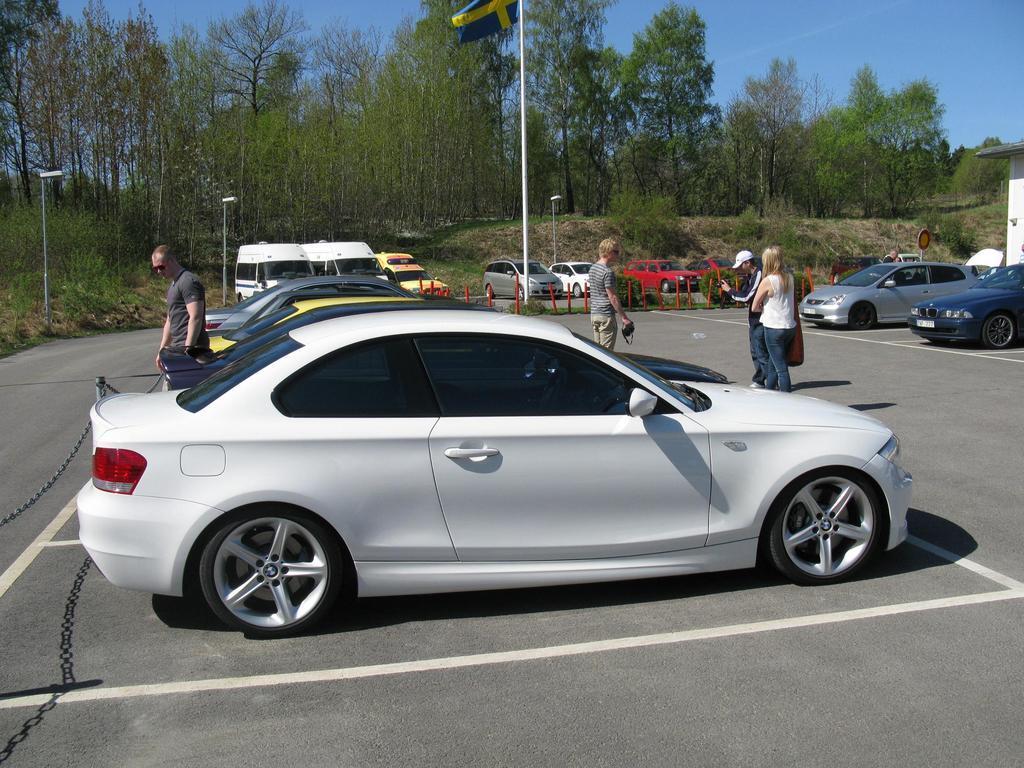Could you give a brief overview of what you see in this image? This is an outside view. Here I can see few vehicles on the road and there are some people standing. On the right side there is a house. In the background, I can see trees and poles. At the top of the image I can see the sky. 